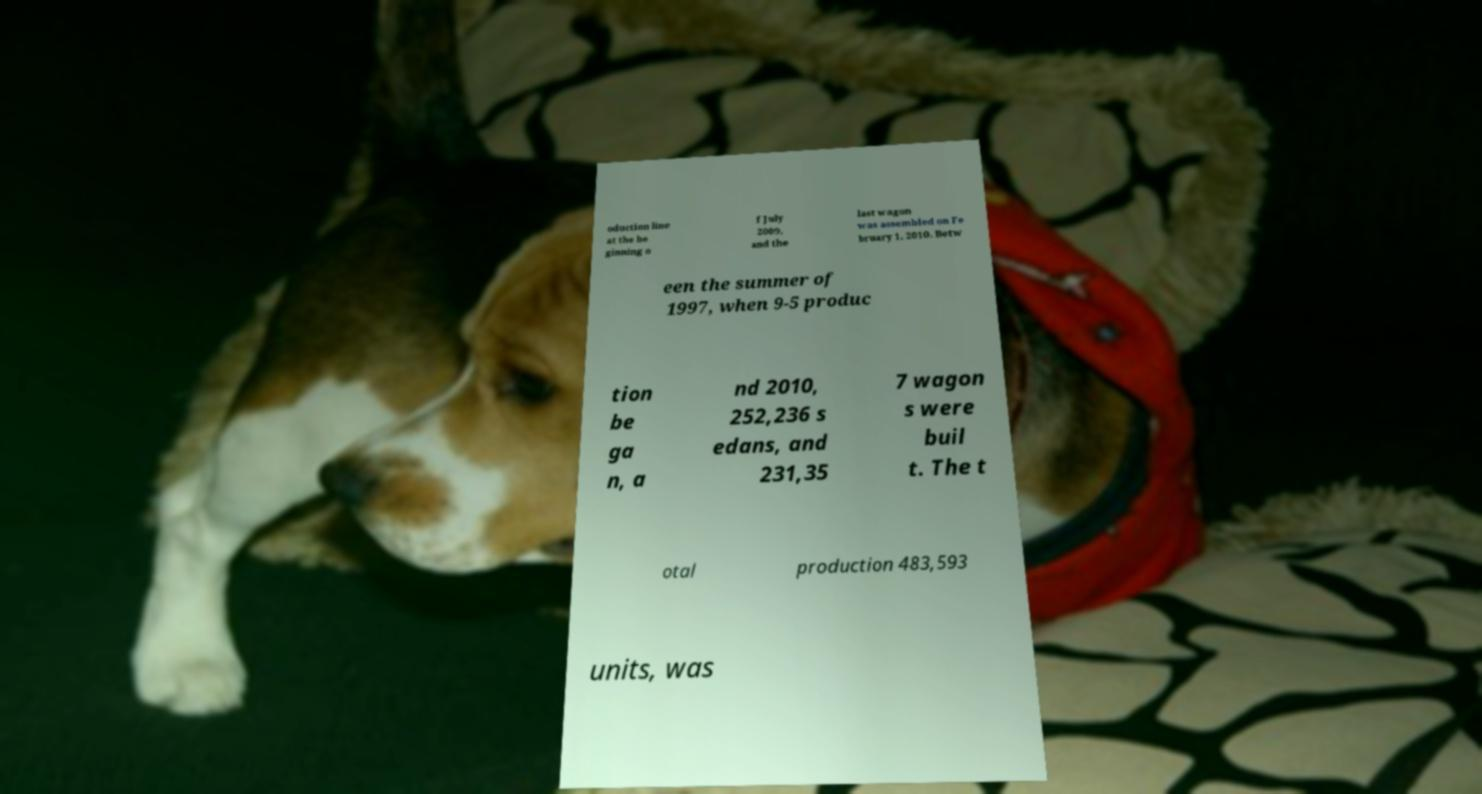For documentation purposes, I need the text within this image transcribed. Could you provide that? oduction line at the be ginning o f July 2009, and the last wagon was assembled on Fe bruary 1, 2010. Betw een the summer of 1997, when 9-5 produc tion be ga n, a nd 2010, 252,236 s edans, and 231,35 7 wagon s were buil t. The t otal production 483,593 units, was 